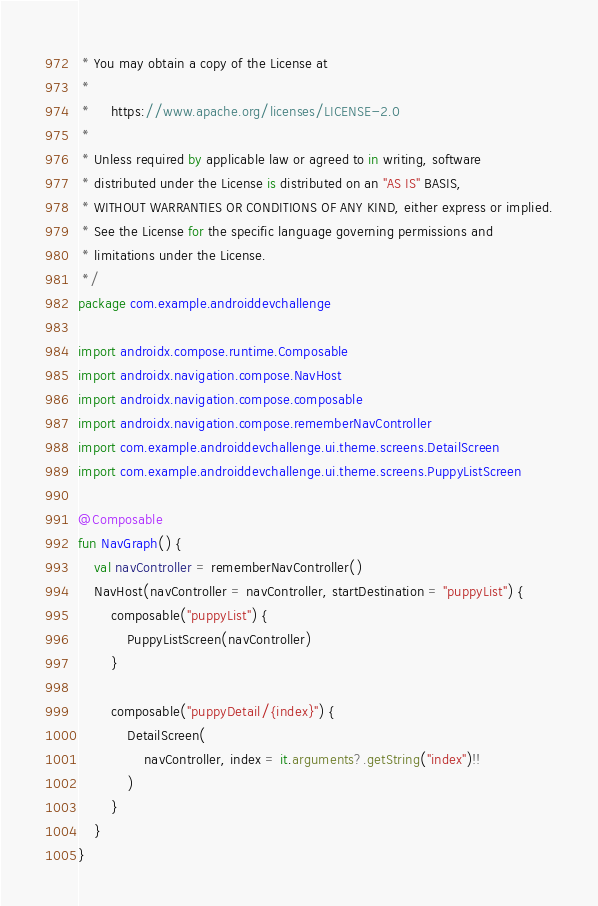Convert code to text. <code><loc_0><loc_0><loc_500><loc_500><_Kotlin_> * You may obtain a copy of the License at
 *
 *     https://www.apache.org/licenses/LICENSE-2.0
 *
 * Unless required by applicable law or agreed to in writing, software
 * distributed under the License is distributed on an "AS IS" BASIS,
 * WITHOUT WARRANTIES OR CONDITIONS OF ANY KIND, either express or implied.
 * See the License for the specific language governing permissions and
 * limitations under the License.
 */
package com.example.androiddevchallenge

import androidx.compose.runtime.Composable
import androidx.navigation.compose.NavHost
import androidx.navigation.compose.composable
import androidx.navigation.compose.rememberNavController
import com.example.androiddevchallenge.ui.theme.screens.DetailScreen
import com.example.androiddevchallenge.ui.theme.screens.PuppyListScreen

@Composable
fun NavGraph() {
    val navController = rememberNavController()
    NavHost(navController = navController, startDestination = "puppyList") {
        composable("puppyList") {
            PuppyListScreen(navController)
        }

        composable("puppyDetail/{index}") {
            DetailScreen(
                navController, index = it.arguments?.getString("index")!!
            )
        }
    }
}
</code> 